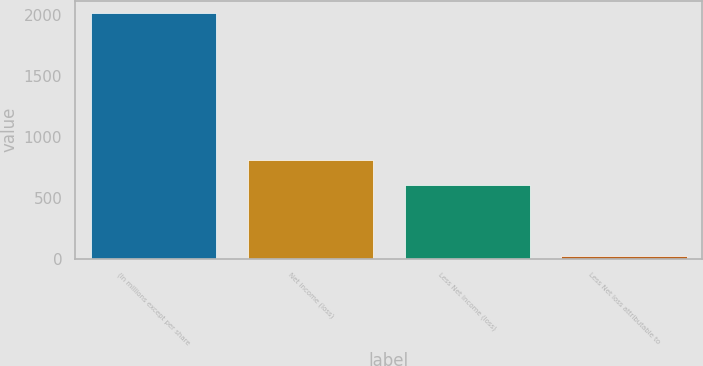Convert chart. <chart><loc_0><loc_0><loc_500><loc_500><bar_chart><fcel>(In millions except per share<fcel>Net income (loss)<fcel>Less Net income (loss)<fcel>Less Net loss attributable to<nl><fcel>2015<fcel>805<fcel>606<fcel>25<nl></chart> 